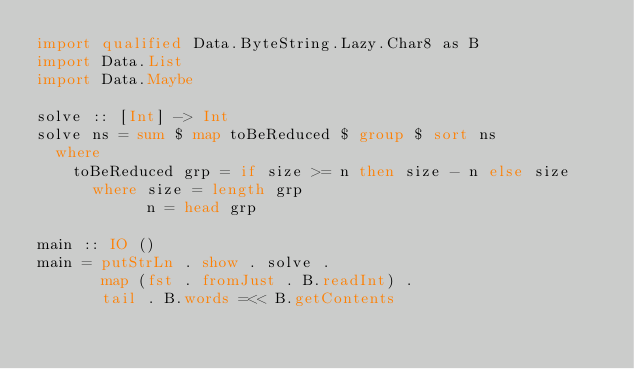<code> <loc_0><loc_0><loc_500><loc_500><_Haskell_>import qualified Data.ByteString.Lazy.Char8 as B
import Data.List
import Data.Maybe

solve :: [Int] -> Int
solve ns = sum $ map toBeReduced $ group $ sort ns
  where
    toBeReduced grp = if size >= n then size - n else size
      where size = length grp
            n = head grp

main :: IO ()
main = putStrLn . show . solve .
       map (fst . fromJust . B.readInt) .
       tail . B.words =<< B.getContents
</code> 